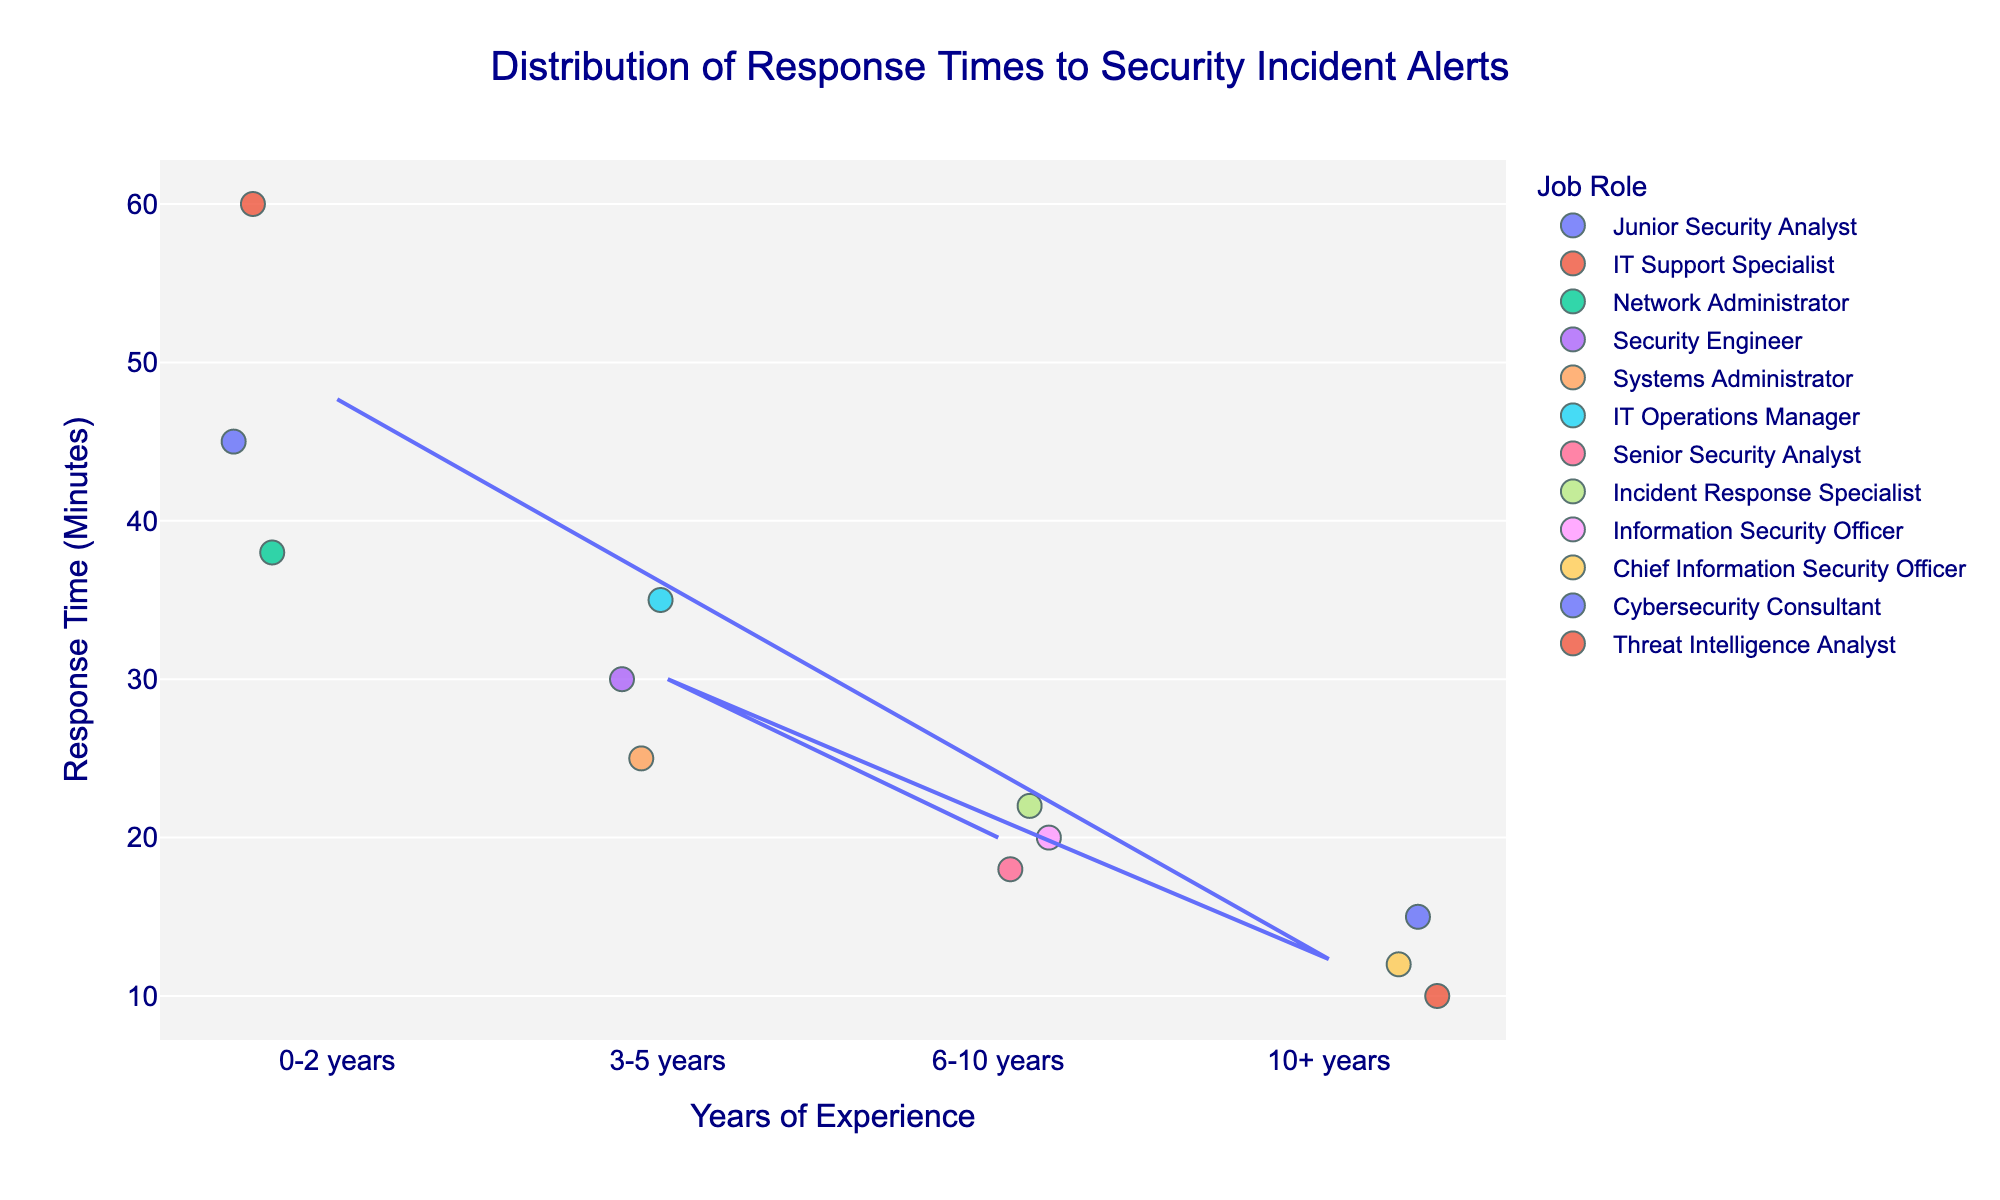What is the title of the figure? We can look at the top of the figure where the title is typically located. The title for the plot appears prominently in a larger font.
Answer: Distribution of Response Times to Security Incident Alerts How many experience levels are represented in the plot? We need to count the distinct categories on the x-axis. The distinct groups listed are "0-2 years", "3-5 years", "6-10 years", and "10+ years".
Answer: 4 Which experience level has the fastest average response time? We look at the trend line added to the plot, which indicates the average response times per experience level. We identify the group with the lowest average.
Answer: 10+ years What is the response time range for IT professionals with 0-2 years of experience? We locate the "0-2 years" group on the x-axis and observe the distribution of response times in that strip. The lowest time is 38 minutes, and the highest time is 60 minutes.
Answer: 38 to 60 minutes Who has the shortest response time overall, and what is their job role? We examine all data points in the plot and find the minimum value. The shortest response time is 10 minutes by the Threat Intelligence Analyst in the 10+ years category.
Answer: Threat Intelligence Analyst What is the difference between the average response time of professionals with 3-5 years of experience and those with 6-10 years? We identify the average response times for each group using the trend line. The average for 3-5 years is 30 minutes, and for 6-10 years is 20 minutes. The difference is 30 - 20.
Answer: 10 minutes Which job role has the widest distribution of response times? We compare the spread of data points for each job role across all experience levels. The role with the most varied response times is typically indicated by the broadest spread along the y-axis.
Answer: Junior Security Analyst Does any experience level have overlapping response times across different job roles? We look for overlapping y-values within each experience level group. For example, the "0-2 years" level shows overlapping between 45, 60, and 38 minutes for different roles.
Answer: Yes What response time is the most common for professionals with 10+ years of experience? We examine the density and frequency of data points within the 10+ years category. The point with a high frequency is 12 to 15 minutes appearing across multiple job roles.
Answer: 15 minutes Which professionals from the 10+ years group responded under 15 minutes? We locate points in the 10+ years group that fall below 15 minutes mark. The professionals are Chief Information Security Officer and Threat Intelligence Analyst.
Answer: Chief Information Security Officer and Threat Intelligence Analyst 